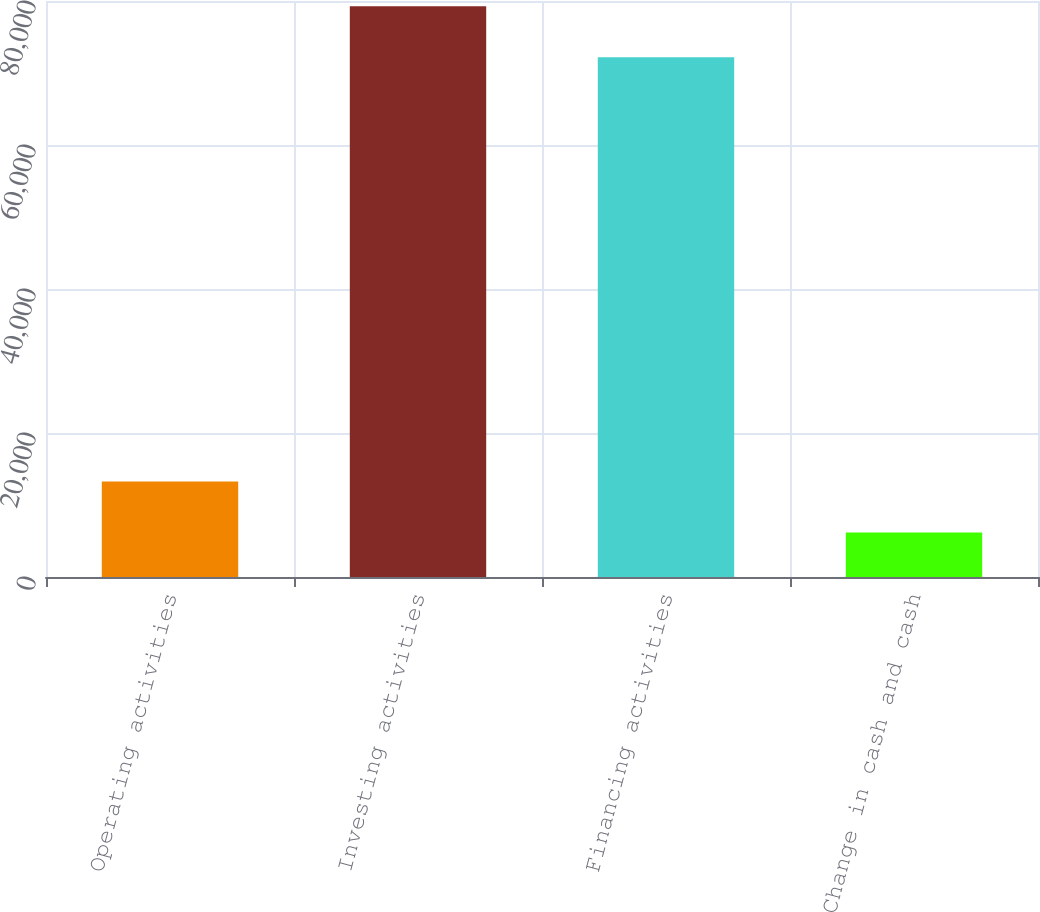Convert chart to OTSL. <chart><loc_0><loc_0><loc_500><loc_500><bar_chart><fcel>Operating activities<fcel>Investing activities<fcel>Financing activities<fcel>Change in cash and cash<nl><fcel>13263<fcel>79272<fcel>72192<fcel>6183<nl></chart> 